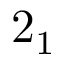<formula> <loc_0><loc_0><loc_500><loc_500>2 _ { 1 }</formula> 